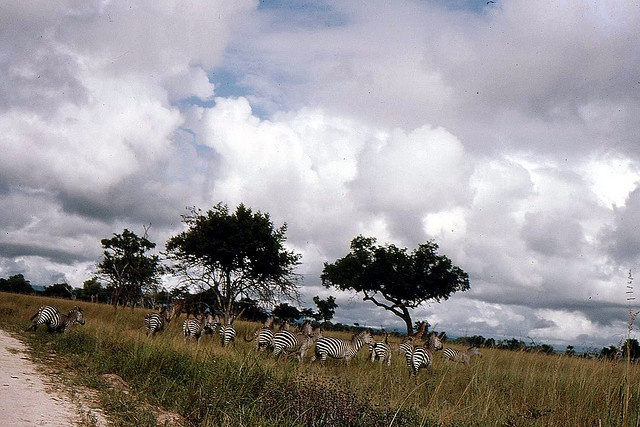Describe the objects in this image and their specific colors. I can see zebra in darkgray, black, and gray tones, zebra in darkgray, black, and gray tones, zebra in darkgray, black, olive, and gray tones, zebra in darkgray, black, olive, and gray tones, and zebra in darkgray, black, gray, and white tones in this image. 